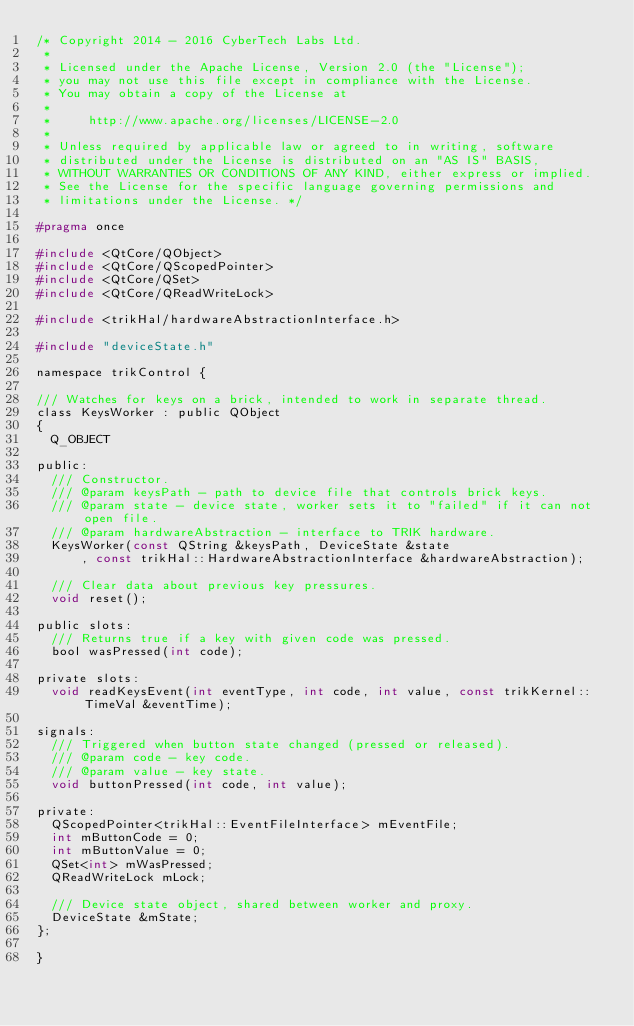<code> <loc_0><loc_0><loc_500><loc_500><_C_>/* Copyright 2014 - 2016 CyberTech Labs Ltd.
 *
 * Licensed under the Apache License, Version 2.0 (the "License");
 * you may not use this file except in compliance with the License.
 * You may obtain a copy of the License at
 *
 *     http://www.apache.org/licenses/LICENSE-2.0
 *
 * Unless required by applicable law or agreed to in writing, software
 * distributed under the License is distributed on an "AS IS" BASIS,
 * WITHOUT WARRANTIES OR CONDITIONS OF ANY KIND, either express or implied.
 * See the License for the specific language governing permissions and
 * limitations under the License. */

#pragma once

#include <QtCore/QObject>
#include <QtCore/QScopedPointer>
#include <QtCore/QSet>
#include <QtCore/QReadWriteLock>

#include <trikHal/hardwareAbstractionInterface.h>

#include "deviceState.h"

namespace trikControl {

/// Watches for keys on a brick, intended to work in separate thread.
class KeysWorker : public QObject
{
	Q_OBJECT

public:
	/// Constructor.
	/// @param keysPath - path to device file that controls brick keys.
	/// @param state - device state, worker sets it to "failed" if it can not open file.
	/// @param hardwareAbstraction - interface to TRIK hardware.
	KeysWorker(const QString &keysPath, DeviceState &state
			, const trikHal::HardwareAbstractionInterface &hardwareAbstraction);

	/// Clear data about previous key pressures.
	void reset();

public slots:
	/// Returns true if a key with given code was pressed.
	bool wasPressed(int code);

private slots:
	void readKeysEvent(int eventType, int code, int value, const trikKernel::TimeVal &eventTime);

signals:
	/// Triggered when button state changed (pressed or released).
	/// @param code - key code.
	/// @param value - key state.
	void buttonPressed(int code, int value);

private:
	QScopedPointer<trikHal::EventFileInterface> mEventFile;
	int mButtonCode = 0;
	int mButtonValue = 0;
	QSet<int> mWasPressed;
	QReadWriteLock mLock;

	/// Device state object, shared between worker and proxy.
	DeviceState &mState;
};

}
</code> 